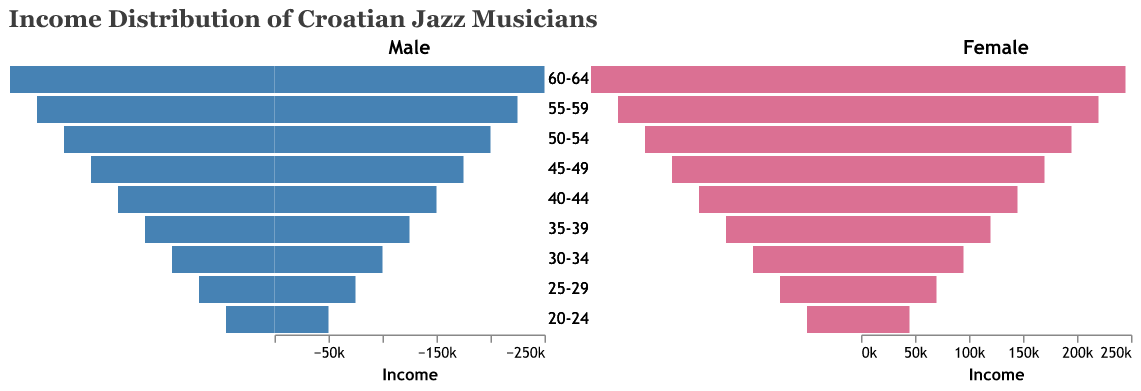What is the income of male jazz musicians aged 40-44? Look at the bar for male musicians in the 40-44 age group and read the value from the x-axis.
Answer: 150,000 HRK What is the income difference between female musicians aged 60-64 and those aged 30-34? Female musicians aged 60-64 earn 245,000 HRK, while those aged 30-34 earn 95,000 HRK. The difference is 245,000 - 95,000.
Answer: 150,000 HRK Who has a higher average income, male or female musicians aged 35-39? Find the incomes for both male and female musicians aged 35-39. Male income: 125,000 HRK, Female income: 120,000 HRK. The average income for males is higher.
Answer: Male Which age group of female musicians has the lowest income? Compare all the income bars for female musicians across age groups and identify the lowest. The lowest income bar corresponds to the 20-24 age group.
Answer: 20-24 What is the total income for male musicians aged 50-54 and 55-59? Add the incomes for male musicians in the 50-54 (200,000 HRK) and 55-59 (225,000 HRK) age groups.
Answer: 425,000 HRK How does the income of female musicians aged 25-29 compare to that of male musicians in the same age group? Compare the heights of the income bars for both genders aged 25-29. The incomes are 70,000 HRK for females and 75,000 HRK for males.
Answer: Lower What is the median income of female jazz musicians? Rank the incomes of all female age groups (45,000, 70,000, 95,000, 120,000, 145,000, 170,000, 195,000, 220,000, 245,000). The median is the middle value.
Answer: 145,000 HRK What is the range of incomes for male musicians? Find the minimum and maximum incomes for male musicians (50,000 HRK to 250,000 HRK). The range is the difference between these two values.
Answer: 200,000 HRK Which age group has the highest average income across both genders? Calculate the average income for each age group by summing male and female incomes and dividing by 2. The highest average is for the 60-64 age group ((250,000 + 245,000)/2).
Answer: 60-64 What do the colors in the bars represent? In the figure, blue represents male musicians and pink represents female musicians.
Answer: Gender 